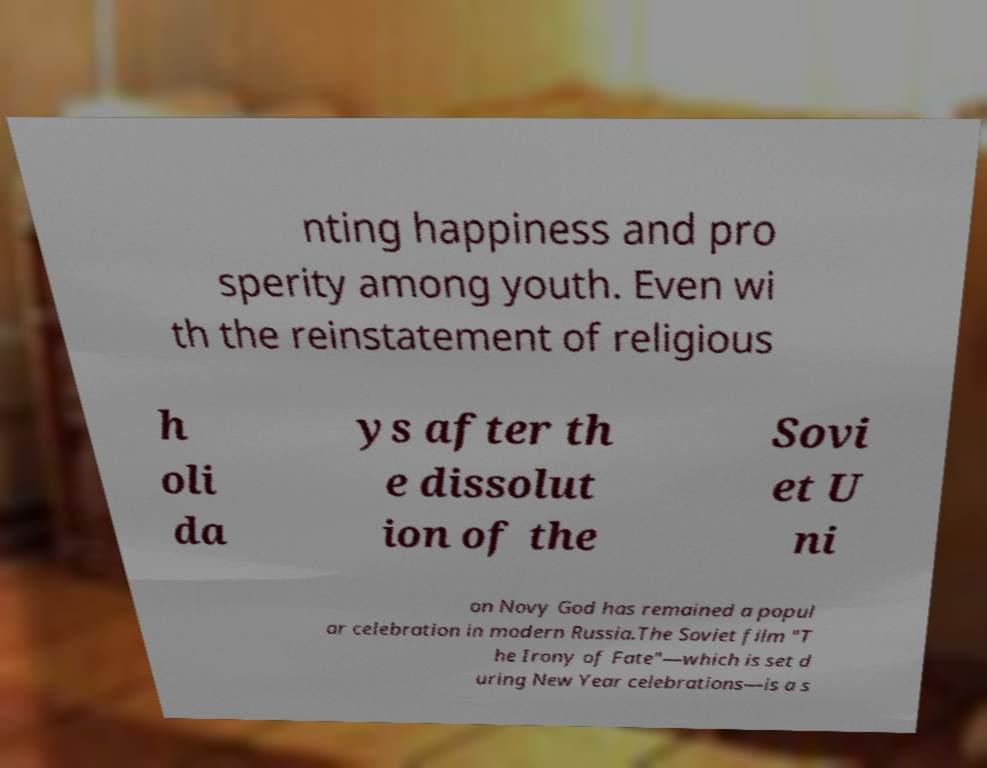There's text embedded in this image that I need extracted. Can you transcribe it verbatim? nting happiness and pro sperity among youth. Even wi th the reinstatement of religious h oli da ys after th e dissolut ion of the Sovi et U ni on Novy God has remained a popul ar celebration in modern Russia.The Soviet film "T he Irony of Fate"—which is set d uring New Year celebrations—is a s 